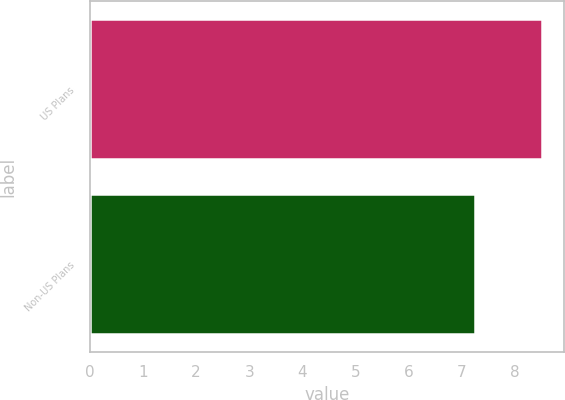<chart> <loc_0><loc_0><loc_500><loc_500><bar_chart><fcel>US Plans<fcel>Non-US Plans<nl><fcel>8.5<fcel>7.24<nl></chart> 